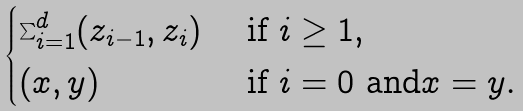<formula> <loc_0><loc_0><loc_500><loc_500>\begin{cases} \sum _ { i = 1 } ^ { d } ( z _ { i - 1 } , z _ { i } ) & \text { if $i\geq 1$,} \\ ( x , y ) & \text { if $i=0$ and$x=y$} . \end{cases}</formula> 